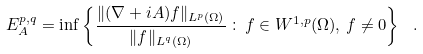Convert formula to latex. <formula><loc_0><loc_0><loc_500><loc_500>E _ { A } ^ { p , q } = \inf \left \{ \frac { \| ( \nabla + i A ) f \| _ { L ^ { p } ( \Omega ) } } { \| f \| _ { L ^ { q } ( \Omega ) } } \, \colon \, f \in W ^ { 1 , p } ( \Omega ) , \, f \neq 0 \right \} \ .</formula> 